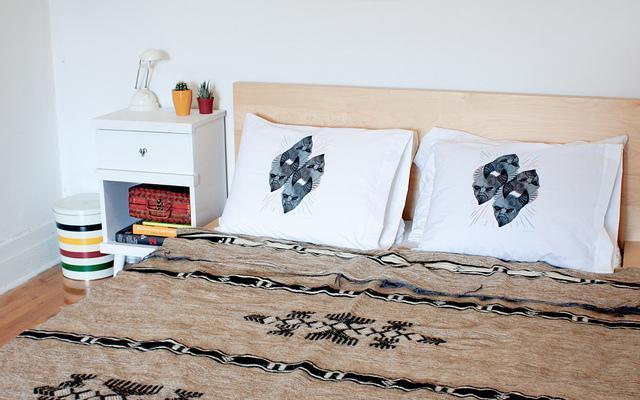How many umbrellas are in the picture?
Give a very brief answer. 0. 